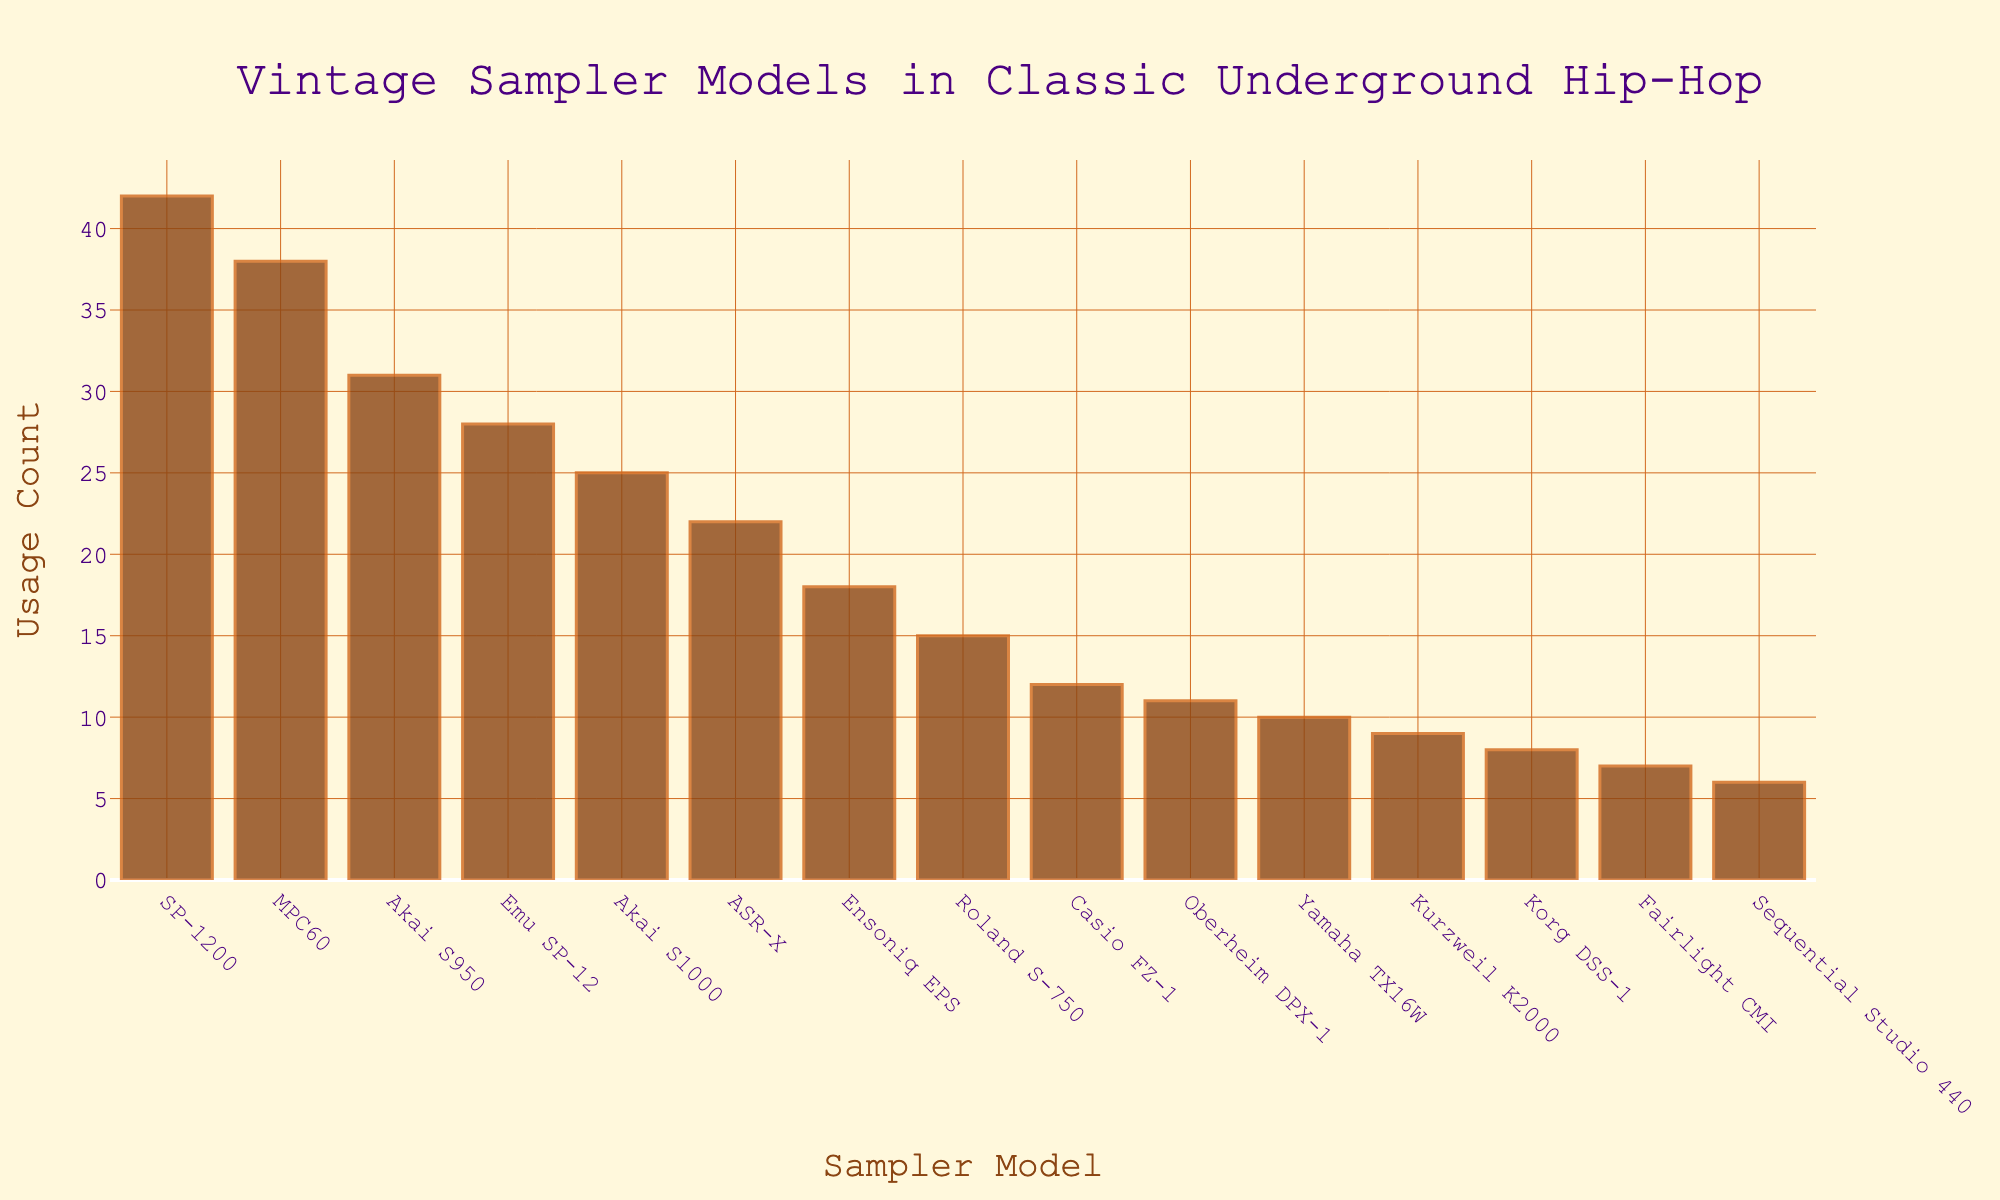Which sampler model has the highest usage count? By looking at the height of the bars, the SP-1200 has the tallest bar, indicating it has the highest usage count.
Answer: SP-1200 Which two models have the closest usage counts? By examining the bar heights, the MPC60 and the Akai S950 have very similar bar heights, suggesting their usage counts are close.
Answer: MPC60 and Akai S950 What's the combined usage count of the Emu SP-12 and the Akai S1000? Adding the usage counts for Emu SP-12 (28) and Akai S1000 (25): 28 + 25 = 53
Answer: 53 Which model has the least usage count? Observing the shortest bar in the chart, the Sequential Studio 440 has the lowest usage count.
Answer: Sequential Studio 440 How many sampler models have a usage count greater than 30? Models with bars taller than 30 on the y-axis are SP-1200 (42), MPC60 (38), and Akai S950 (31). There are three such models.
Answer: 3 What is the average usage count of the Akai S950 and the Ensoniq EPS? Adding the counts for Akai S950 (31) and Ensoniq EPS (18) and then dividing by 2: (31 + 18) / 2 = 24.5
Answer: 24.5 Which models have a usage count between 20 and 30? Observing the bars whose heights fall in the 20-30 range on the y-axis. These models are ASR-X (22), Akai S1000 (25), and Emu SP-12 (28).
Answer: ASR-X, Akai S1000, Emu SP-12 What's the difference in usage count between the model with the highest count and the model with the second highest count? Subtracting the second highest count (MPC60 with 38) from the highest count (SP-1200 with 42): 42 - 38 = 4
Answer: 4 What is the usage count range for the sampler models? The range is calculated by subtracting the usage count of the model with the lowest value (Sequential Studio 440 with 6) from the model with the highest value (SP-1200 with 42): 42 - 6 = 36
Answer: 36 Which two models have the closest usage counts below 20? By comparing the bars representing models with usage counts below 20, the Yamaha TX16W (10) and Korg DSS-1 (8) have the closest values.
Answer: Yamaha TX16W and Korg DSS-1 